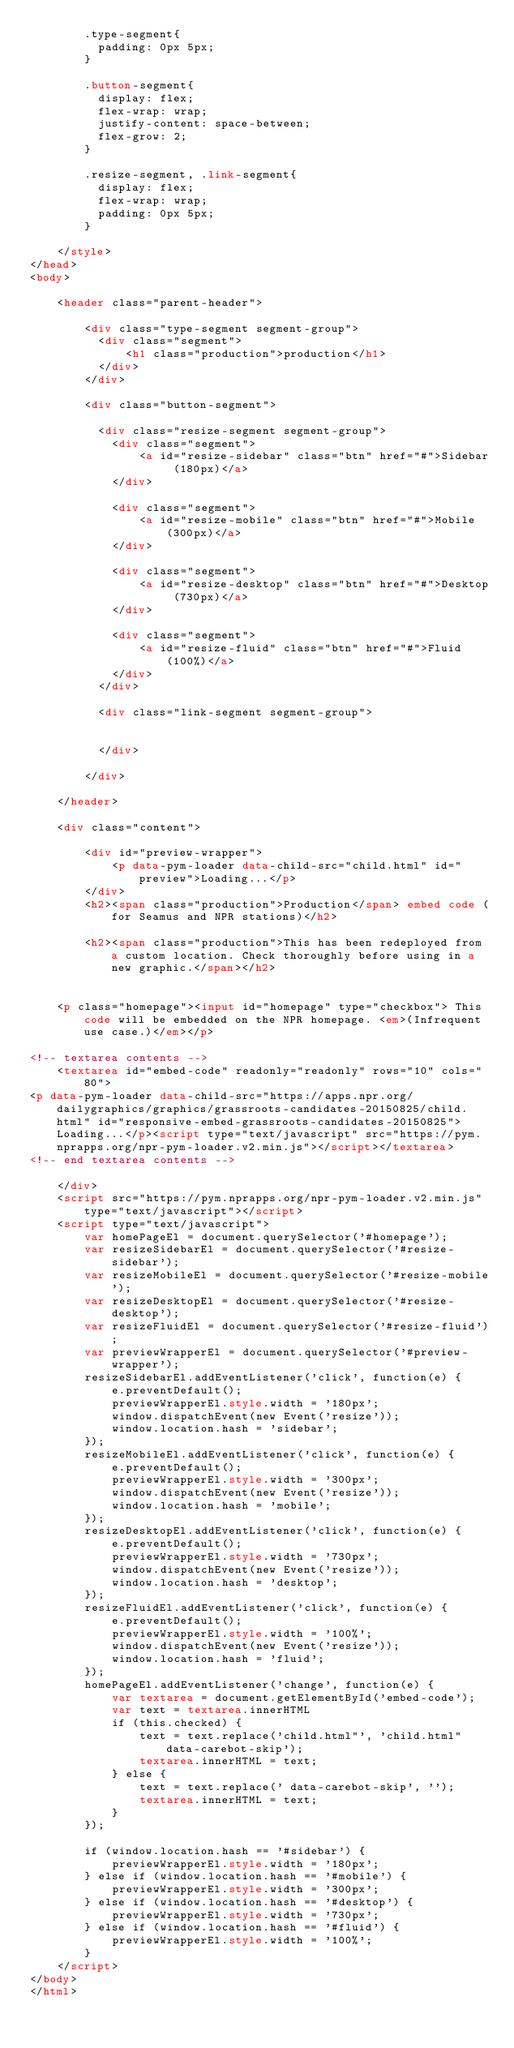<code> <loc_0><loc_0><loc_500><loc_500><_HTML_>        .type-segment{
          padding: 0px 5px;
        }

        .button-segment{
          display: flex;
          flex-wrap: wrap;
          justify-content: space-between;
          flex-grow: 2;
        }

        .resize-segment, .link-segment{
          display: flex;
          flex-wrap: wrap;
          padding: 0px 5px;
        }

    </style>
</head>
<body>

    <header class="parent-header">

        <div class="type-segment segment-group">
          <div class="segment">
              <h1 class="production">production</h1>
          </div>
        </div>

        <div class="button-segment">

          <div class="resize-segment segment-group">
            <div class="segment">
                <a id="resize-sidebar" class="btn" href="#">Sidebar (180px)</a>
            </div>

            <div class="segment">
                <a id="resize-mobile" class="btn" href="#">Mobile (300px)</a>
            </div>

            <div class="segment">
                <a id="resize-desktop" class="btn" href="#">Desktop (730px)</a>
            </div>

            <div class="segment">
                <a id="resize-fluid" class="btn" href="#">Fluid (100%)</a>
            </div>
          </div>

          <div class="link-segment segment-group">

              
          </div>

        </div>

    </header>

    <div class="content">

        <div id="preview-wrapper">
            <p data-pym-loader data-child-src="child.html" id="preview">Loading...</p>
        </div>
        <h2><span class="production">Production</span> embed code (for Seamus and NPR stations)</h2>

        <h2><span class="production">This has been redeployed from a custom location. Check thoroughly before using in a new graphic.</span></h2>


    <p class="homepage"><input id="homepage" type="checkbox"> This code will be embedded on the NPR homepage. <em>(Infrequent use case.)</em></p>

<!-- textarea contents -->
    <textarea id="embed-code" readonly="readonly" rows="10" cols="80">
<p data-pym-loader data-child-src="https://apps.npr.org/dailygraphics/graphics/grassroots-candidates-20150825/child.html" id="responsive-embed-grassroots-candidates-20150825">Loading...</p><script type="text/javascript" src="https://pym.nprapps.org/npr-pym-loader.v2.min.js"></script></textarea>
<!-- end textarea contents -->

    </div>
    <script src="https://pym.nprapps.org/npr-pym-loader.v2.min.js" type="text/javascript"></script>
    <script type="text/javascript">
        var homePageEl = document.querySelector('#homepage');
        var resizeSidebarEl = document.querySelector('#resize-sidebar');
        var resizeMobileEl = document.querySelector('#resize-mobile');
        var resizeDesktopEl = document.querySelector('#resize-desktop');
        var resizeFluidEl = document.querySelector('#resize-fluid');
        var previewWrapperEl = document.querySelector('#preview-wrapper');
        resizeSidebarEl.addEventListener('click', function(e) {
            e.preventDefault();
            previewWrapperEl.style.width = '180px';
            window.dispatchEvent(new Event('resize'));
            window.location.hash = 'sidebar';
        });
        resizeMobileEl.addEventListener('click', function(e) {
            e.preventDefault();
            previewWrapperEl.style.width = '300px';
            window.dispatchEvent(new Event('resize'));
            window.location.hash = 'mobile';
        });
        resizeDesktopEl.addEventListener('click', function(e) {
            e.preventDefault();
            previewWrapperEl.style.width = '730px';
            window.dispatchEvent(new Event('resize'));
            window.location.hash = 'desktop';
        });
        resizeFluidEl.addEventListener('click', function(e) {
            e.preventDefault();
            previewWrapperEl.style.width = '100%';
            window.dispatchEvent(new Event('resize'));
            window.location.hash = 'fluid';
        });
        homePageEl.addEventListener('change', function(e) {
            var textarea = document.getElementById('embed-code');
            var text = textarea.innerHTML
            if (this.checked) {
                text = text.replace('child.html"', 'child.html" data-carebot-skip');
                textarea.innerHTML = text;
            } else {
                text = text.replace(' data-carebot-skip', '');
                textarea.innerHTML = text;
            }
        });

        if (window.location.hash == '#sidebar') {
            previewWrapperEl.style.width = '180px';
        } else if (window.location.hash == '#mobile') {
            previewWrapperEl.style.width = '300px';
        } else if (window.location.hash == '#desktop') {
            previewWrapperEl.style.width = '730px';
        } else if (window.location.hash == '#fluid') {
            previewWrapperEl.style.width = '100%';
        }
    </script>
</body>
</html></code> 